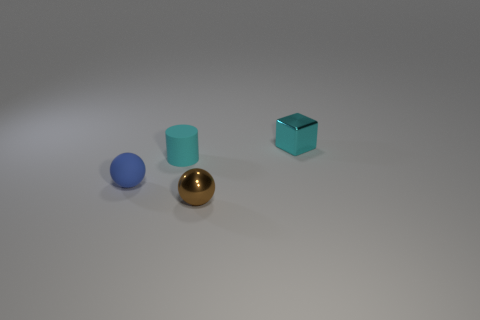What is the material of the small cube that is the same color as the cylinder?
Offer a terse response. Metal. How many metal things have the same shape as the cyan rubber thing?
Offer a terse response. 0. Is the number of blocks that are behind the small shiny sphere greater than the number of large green cubes?
Your answer should be compact. Yes. What shape is the rubber object that is behind the tiny blue rubber thing behind the shiny object left of the cyan metal cube?
Offer a very short reply. Cylinder. Do the small shiny object in front of the cyan matte thing and the small blue rubber object that is on the left side of the metal block have the same shape?
Keep it short and to the point. Yes. How many balls are either brown things or tiny things?
Provide a short and direct response. 2. Are the blue object and the small brown ball made of the same material?
Ensure brevity in your answer.  No. What number of other things are the same color as the metallic ball?
Give a very brief answer. 0. There is a cyan object that is to the left of the tiny metallic cube; what is its shape?
Your answer should be compact. Cylinder. What number of objects are cyan objects or brown things?
Ensure brevity in your answer.  3. 